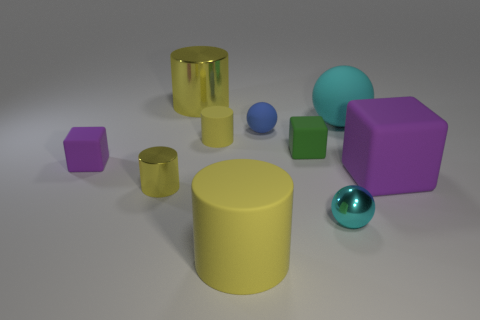Is the number of tiny rubber objects that are in front of the cyan matte sphere greater than the number of small objects that are to the left of the tiny purple matte thing?
Offer a terse response. Yes. The green thing is what size?
Your answer should be very brief. Small. The big yellow object that is in front of the big metal thing has what shape?
Ensure brevity in your answer.  Cylinder. Does the small blue matte object have the same shape as the small yellow metal thing?
Offer a terse response. No. Is the number of small yellow metal objects that are in front of the big yellow matte cylinder the same as the number of small blue spheres?
Make the answer very short. No. What is the shape of the small yellow metallic thing?
Give a very brief answer. Cylinder. Is there any other thing that is the same color as the large block?
Offer a very short reply. Yes. Do the metallic thing that is on the right side of the small blue sphere and the yellow rubber thing that is behind the green matte cube have the same size?
Offer a terse response. Yes. There is a metal object behind the rubber ball that is right of the blue ball; what shape is it?
Your answer should be very brief. Cylinder. Is the size of the blue object the same as the purple block that is on the left side of the large rubber ball?
Offer a terse response. Yes. 